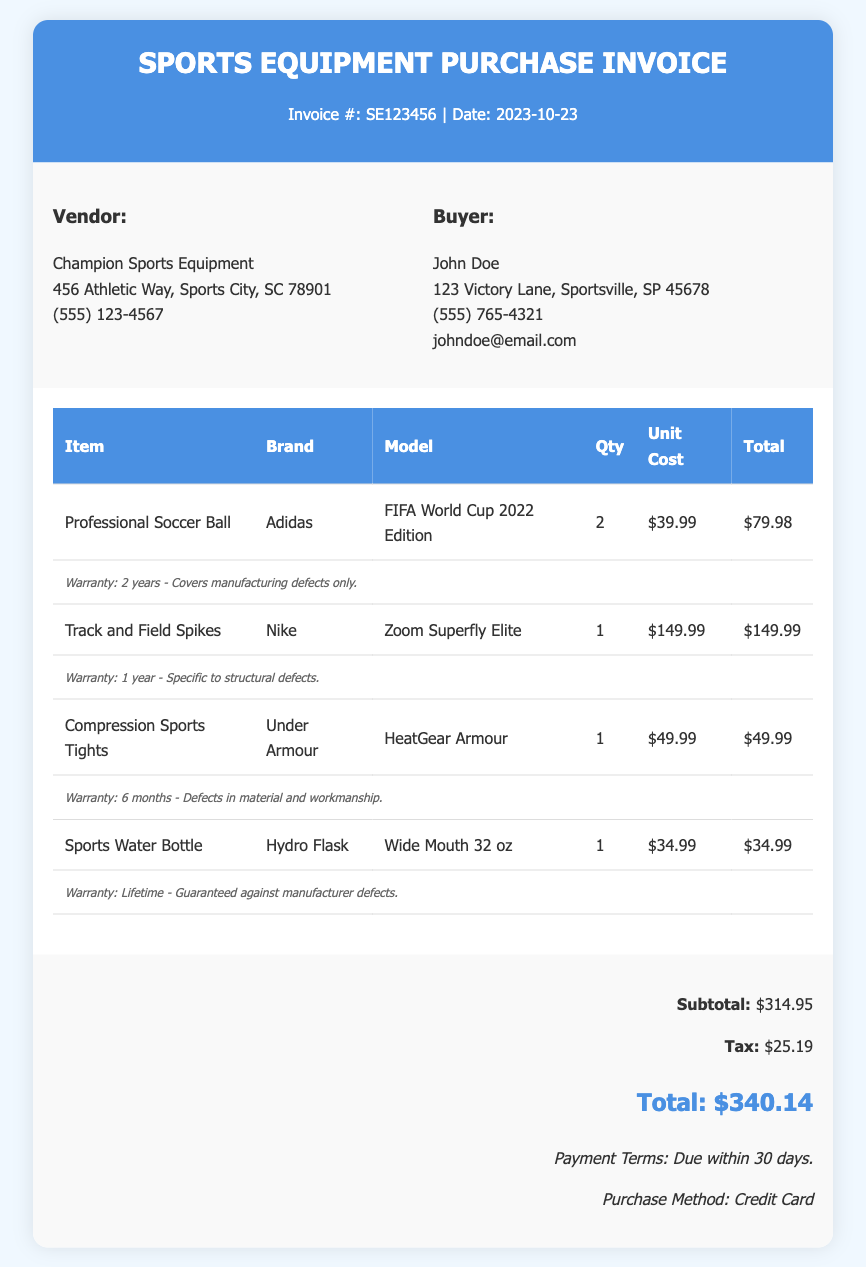What is the invoice number? The invoice number is located at the top of the invoice under the title.
Answer: SE123456 What is the date of the invoice? The date of the invoice is listed below the invoice number.
Answer: 2023-10-23 Who is the vendor? The vendor's name is presented in the invoice details section, identifying who sold the equipment.
Answer: Champion Sports Equipment What is the warranty period for the Professional Soccer Ball? The warranty information is provided below the item details in the invoice.
Answer: 2 years How much did the Compression Sports Tights cost? The cost of the Compression Sports Tights is listed in the itemized section of the invoice.
Answer: $49.99 What is the subtotal amount? The subtotal is found in the invoice summary section.
Answer: $314.95 What is the total cost including tax? The total cost is the final amount calculated in the invoice summary.
Answer: $340.14 What type of purchase method was used? The payment method is mentioned in the invoice summary section.
Answer: Credit Card How many Track and Field Spikes were purchased? The quantity is specified in the invoice under the item details.
Answer: 1 